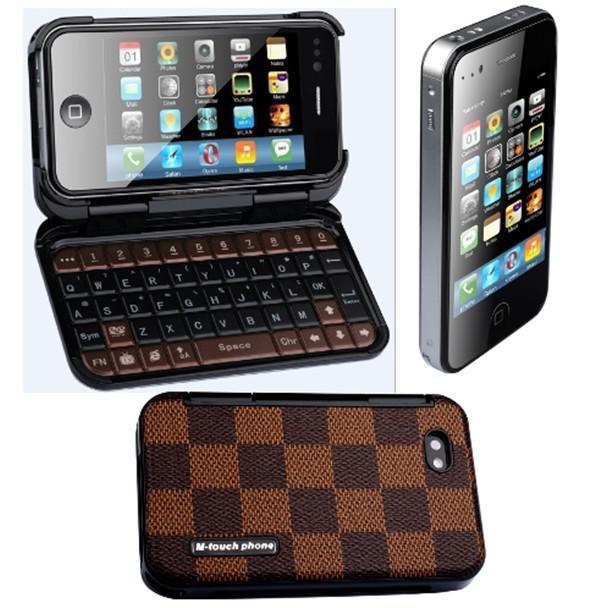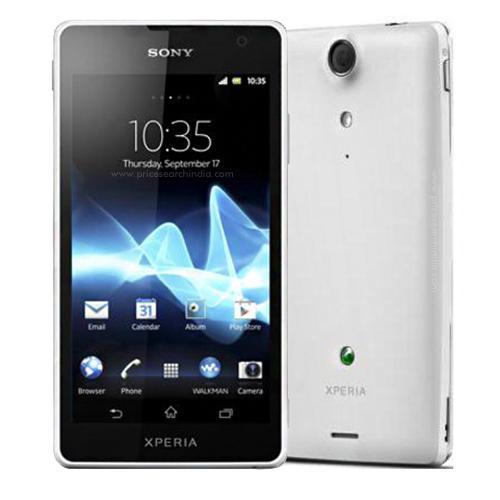The first image is the image on the left, the second image is the image on the right. Evaluate the accuracy of this statement regarding the images: "One of the phones has physical keys.". Is it true? Answer yes or no. Yes. The first image is the image on the left, the second image is the image on the right. Given the left and right images, does the statement "One image shows three screened devices in a row, and each image includes rainbow colors in a curving ribbon shape on at least one screen." hold true? Answer yes or no. No. 